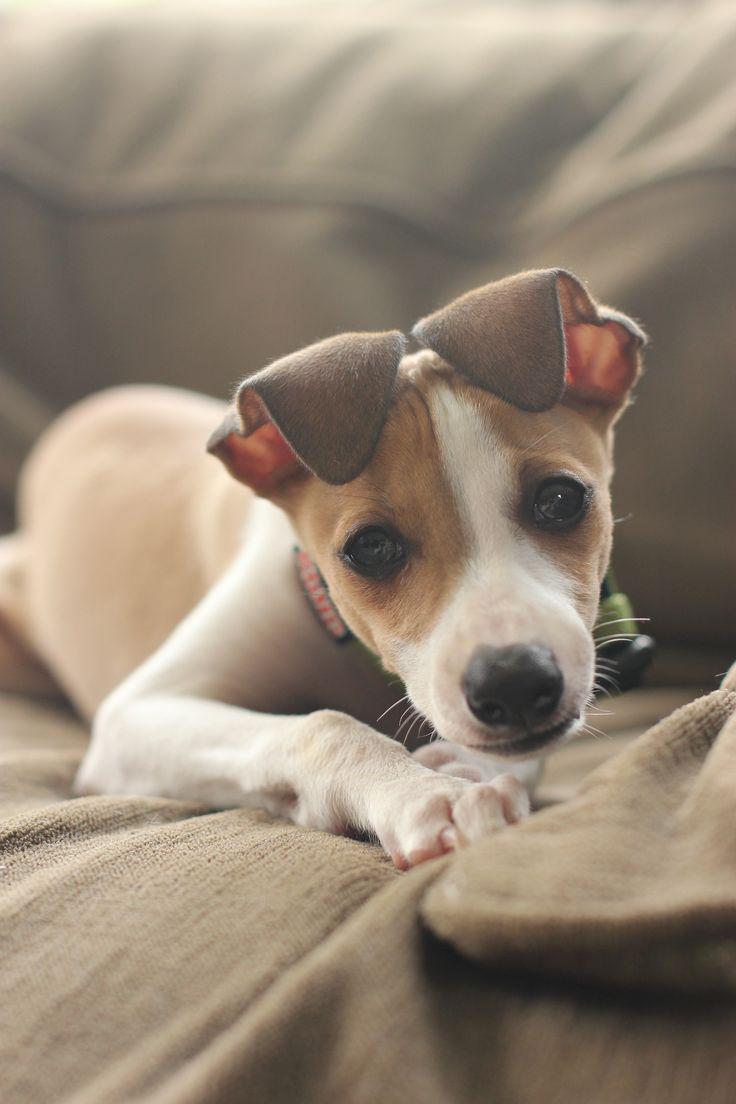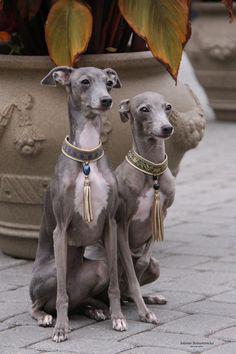The first image is the image on the left, the second image is the image on the right. Given the left and right images, does the statement "Two dogs are sitting next to each other in the image on the right." hold true? Answer yes or no. Yes. The first image is the image on the left, the second image is the image on the right. Assess this claim about the two images: "The right image contains twice as many hound dogs as the left image.". Correct or not? Answer yes or no. Yes. 